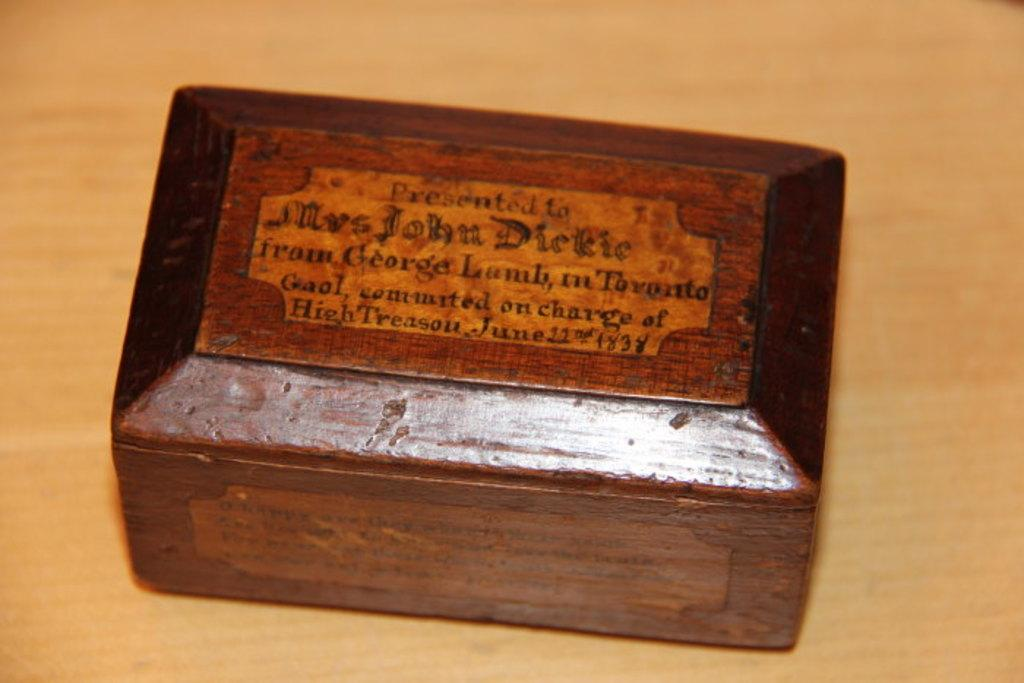<image>
Relay a brief, clear account of the picture shown. Wooden boss inscribed presented to Mrs. John Dickie from George Lamb. 